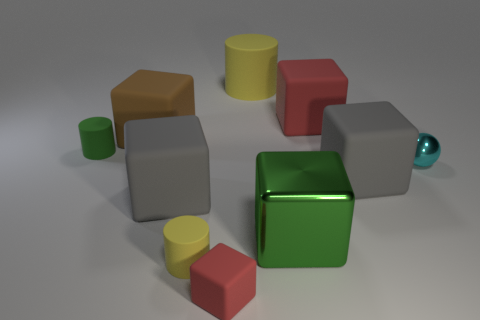Subtract all brown cubes. How many cubes are left? 5 Subtract all brown blocks. How many blocks are left? 5 Subtract 1 blocks. How many blocks are left? 5 Subtract all purple cubes. Subtract all brown cylinders. How many cubes are left? 6 Subtract all balls. How many objects are left? 9 Subtract all small red blocks. Subtract all big gray blocks. How many objects are left? 7 Add 6 large metal cubes. How many large metal cubes are left? 7 Add 8 big yellow cylinders. How many big yellow cylinders exist? 9 Subtract 0 gray cylinders. How many objects are left? 10 